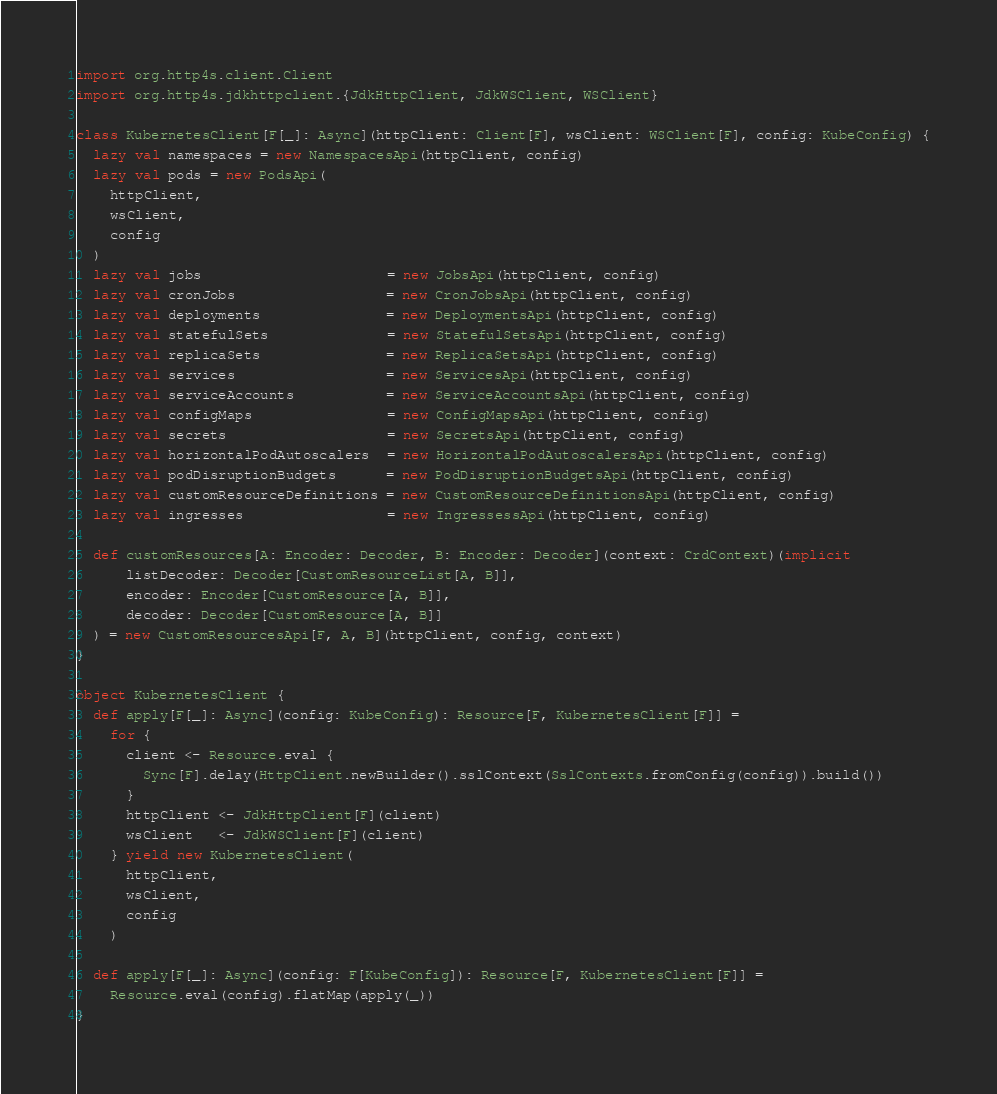<code> <loc_0><loc_0><loc_500><loc_500><_Scala_>import org.http4s.client.Client
import org.http4s.jdkhttpclient.{JdkHttpClient, JdkWSClient, WSClient}

class KubernetesClient[F[_]: Async](httpClient: Client[F], wsClient: WSClient[F], config: KubeConfig) {
  lazy val namespaces = new NamespacesApi(httpClient, config)
  lazy val pods = new PodsApi(
    httpClient,
    wsClient,
    config
  )
  lazy val jobs                      = new JobsApi(httpClient, config)
  lazy val cronJobs                  = new CronJobsApi(httpClient, config)
  lazy val deployments               = new DeploymentsApi(httpClient, config)
  lazy val statefulSets              = new StatefulSetsApi(httpClient, config)
  lazy val replicaSets               = new ReplicaSetsApi(httpClient, config)
  lazy val services                  = new ServicesApi(httpClient, config)
  lazy val serviceAccounts           = new ServiceAccountsApi(httpClient, config)
  lazy val configMaps                = new ConfigMapsApi(httpClient, config)
  lazy val secrets                   = new SecretsApi(httpClient, config)
  lazy val horizontalPodAutoscalers  = new HorizontalPodAutoscalersApi(httpClient, config)
  lazy val podDisruptionBudgets      = new PodDisruptionBudgetsApi(httpClient, config)
  lazy val customResourceDefinitions = new CustomResourceDefinitionsApi(httpClient, config)
  lazy val ingresses                 = new IngressessApi(httpClient, config)

  def customResources[A: Encoder: Decoder, B: Encoder: Decoder](context: CrdContext)(implicit
      listDecoder: Decoder[CustomResourceList[A, B]],
      encoder: Encoder[CustomResource[A, B]],
      decoder: Decoder[CustomResource[A, B]]
  ) = new CustomResourcesApi[F, A, B](httpClient, config, context)
}

object KubernetesClient {
  def apply[F[_]: Async](config: KubeConfig): Resource[F, KubernetesClient[F]] =
    for {
      client <- Resource.eval {
        Sync[F].delay(HttpClient.newBuilder().sslContext(SslContexts.fromConfig(config)).build())
      }
      httpClient <- JdkHttpClient[F](client)
      wsClient   <- JdkWSClient[F](client)
    } yield new KubernetesClient(
      httpClient,
      wsClient,
      config
    )

  def apply[F[_]: Async](config: F[KubeConfig]): Resource[F, KubernetesClient[F]] =
    Resource.eval(config).flatMap(apply(_))
}
</code> 